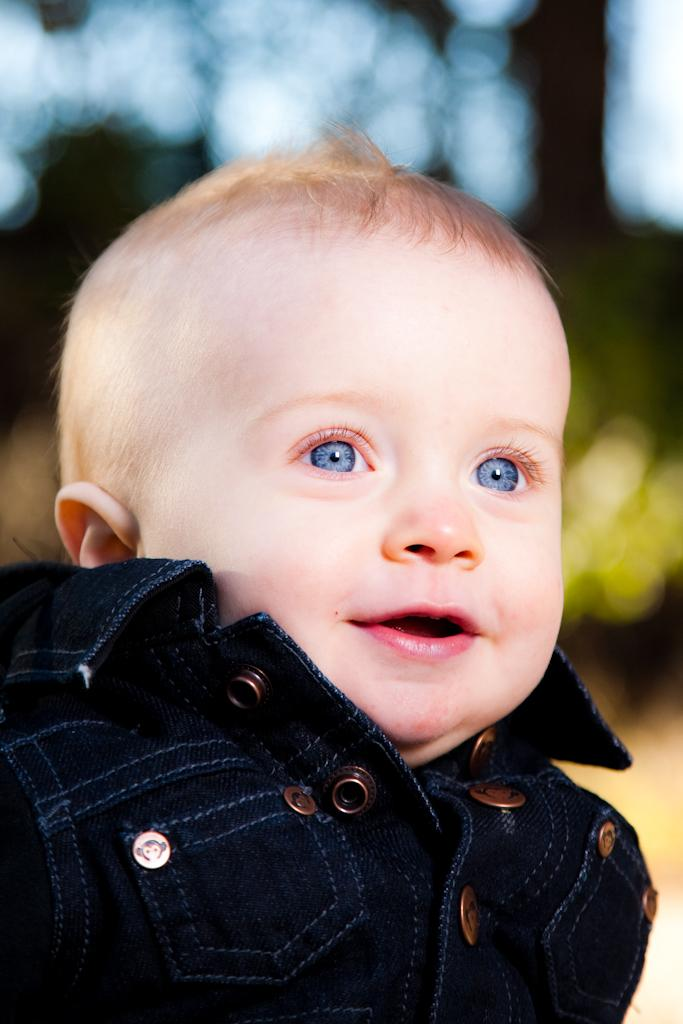What is the main subject of the image? There is a baby in the image. What is the baby wearing? The baby is wearing a black dress. Can you describe the background of the image? The background of the image is blurred. What color is the crayon the baby is holding in the image? There is no crayon present in the image. How does the baby's throat look in the image? The image does not show the baby's throat, so it cannot be determined from the image. 